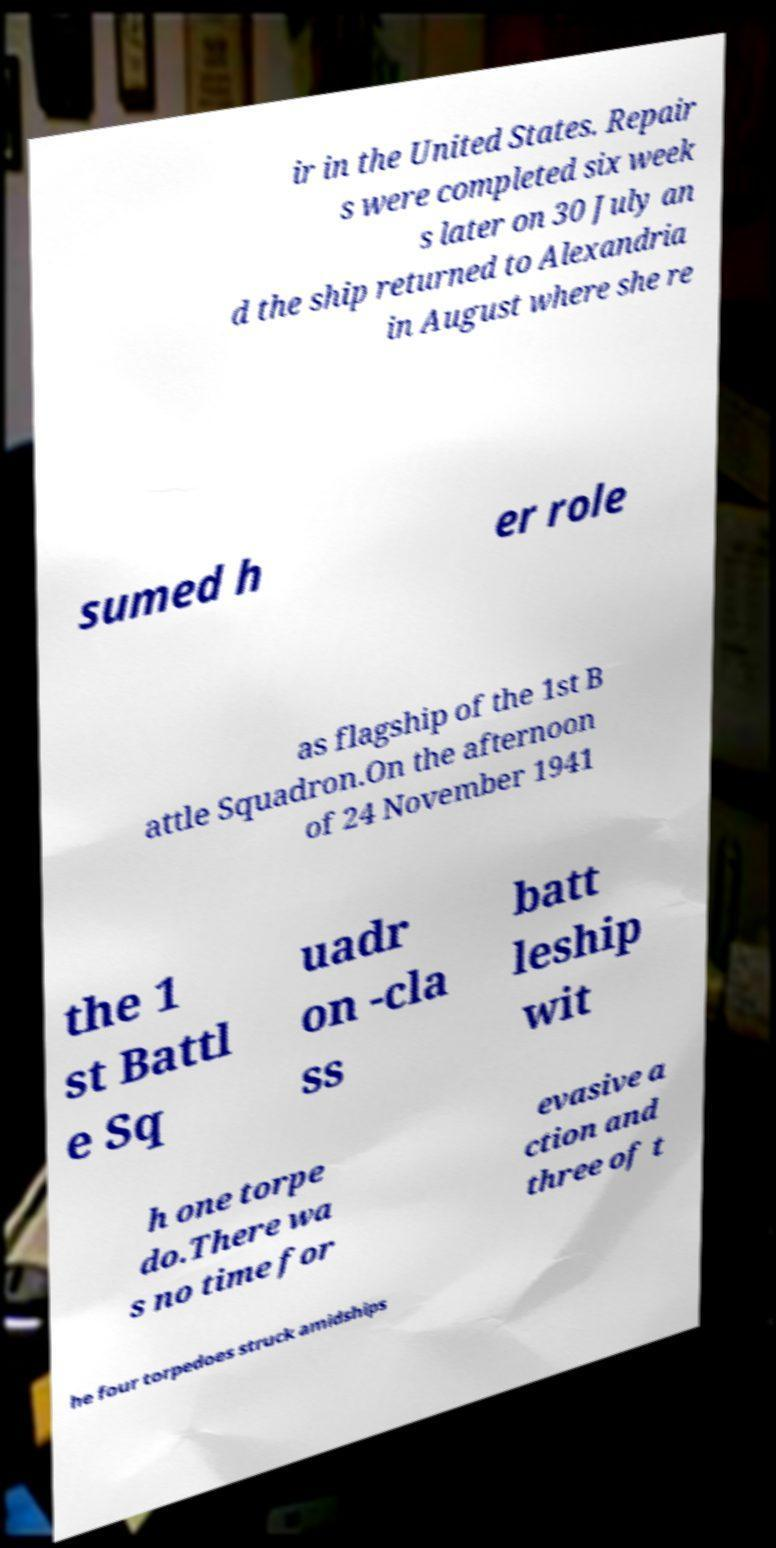There's text embedded in this image that I need extracted. Can you transcribe it verbatim? ir in the United States. Repair s were completed six week s later on 30 July an d the ship returned to Alexandria in August where she re sumed h er role as flagship of the 1st B attle Squadron.On the afternoon of 24 November 1941 the 1 st Battl e Sq uadr on -cla ss batt leship wit h one torpe do.There wa s no time for evasive a ction and three of t he four torpedoes struck amidships 